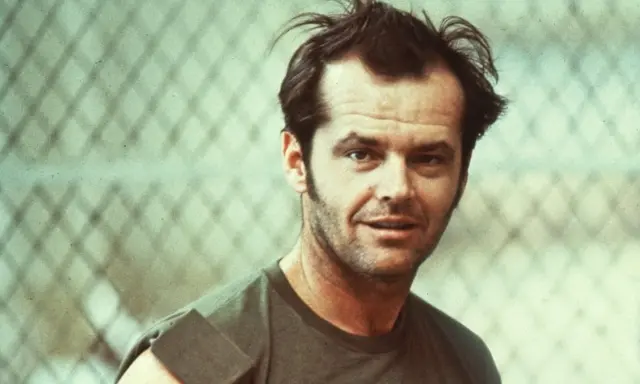If you were to write a short story based on this image, how would it begin? The sun was setting behind the chain-link fence, casting long shadows across the abandoned lot. He stood there, his green tank top darkened by sweat, the humidity of the city evening clinging to his skin. His hair, tousled and wild, framed a face etched with the weight of countless unspoken thoughts. He stared ahead, eyes piercing through the metal grating as if seeing beyond the physical world. In that moment, he knew a change was coming - one that would alter the course of his life forever. 